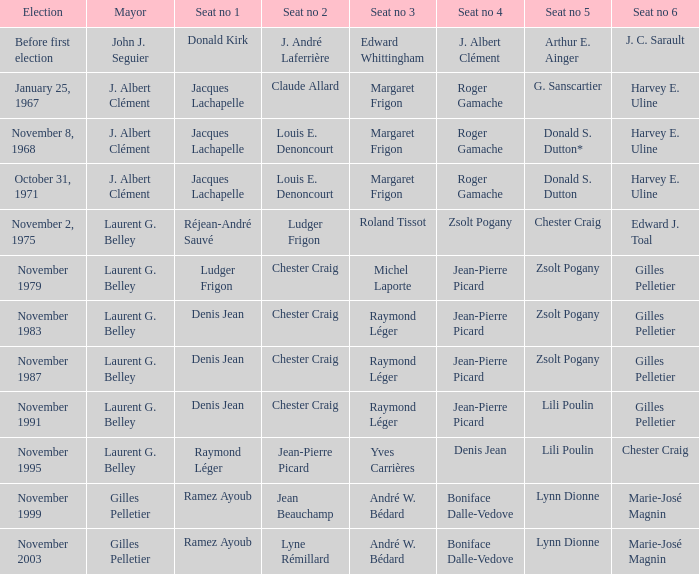In which election was seat 1 held by jacques lachapelle and seat 5 held by g. sanscartier? January 25, 1967. 